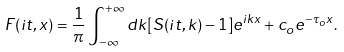Convert formula to latex. <formula><loc_0><loc_0><loc_500><loc_500>F ( i t , x ) = \frac { 1 } { \pi } \int _ { - \infty } ^ { + \infty } d k [ S ( i t , k ) - 1 ] e ^ { i k x } + c _ { o } e ^ { - \tau _ { o } x } .</formula> 